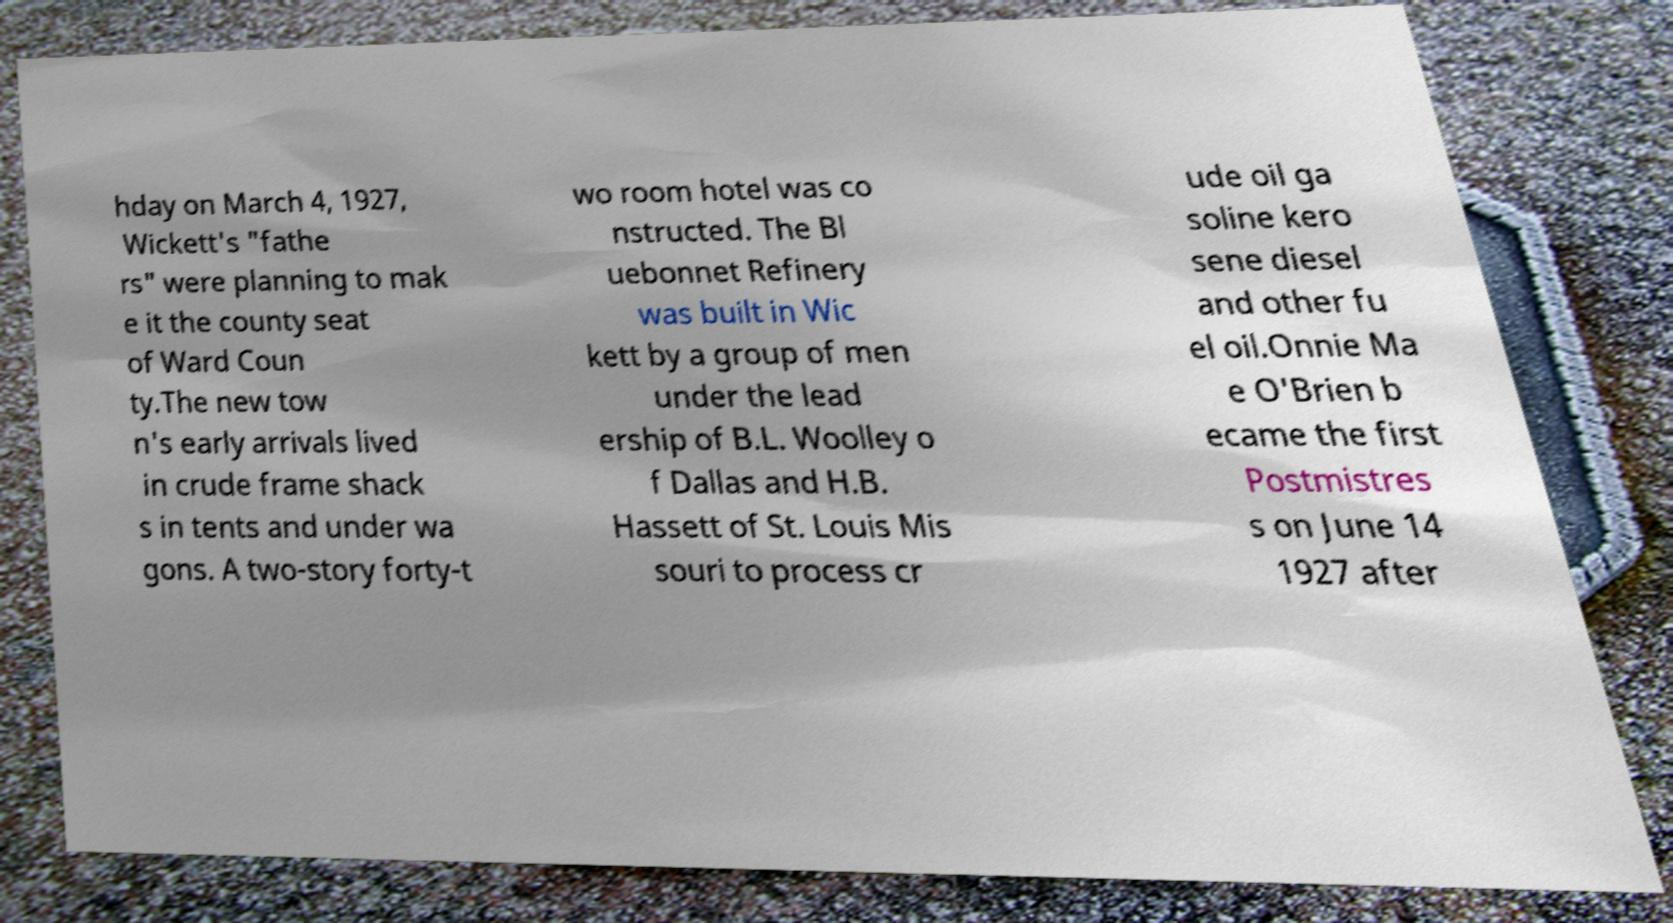Please identify and transcribe the text found in this image. hday on March 4, 1927, Wickett's "fathe rs" were planning to mak e it the county seat of Ward Coun ty.The new tow n's early arrivals lived in crude frame shack s in tents and under wa gons. A two-story forty-t wo room hotel was co nstructed. The Bl uebonnet Refinery was built in Wic kett by a group of men under the lead ership of B.L. Woolley o f Dallas and H.B. Hassett of St. Louis Mis souri to process cr ude oil ga soline kero sene diesel and other fu el oil.Onnie Ma e O'Brien b ecame the first Postmistres s on June 14 1927 after 